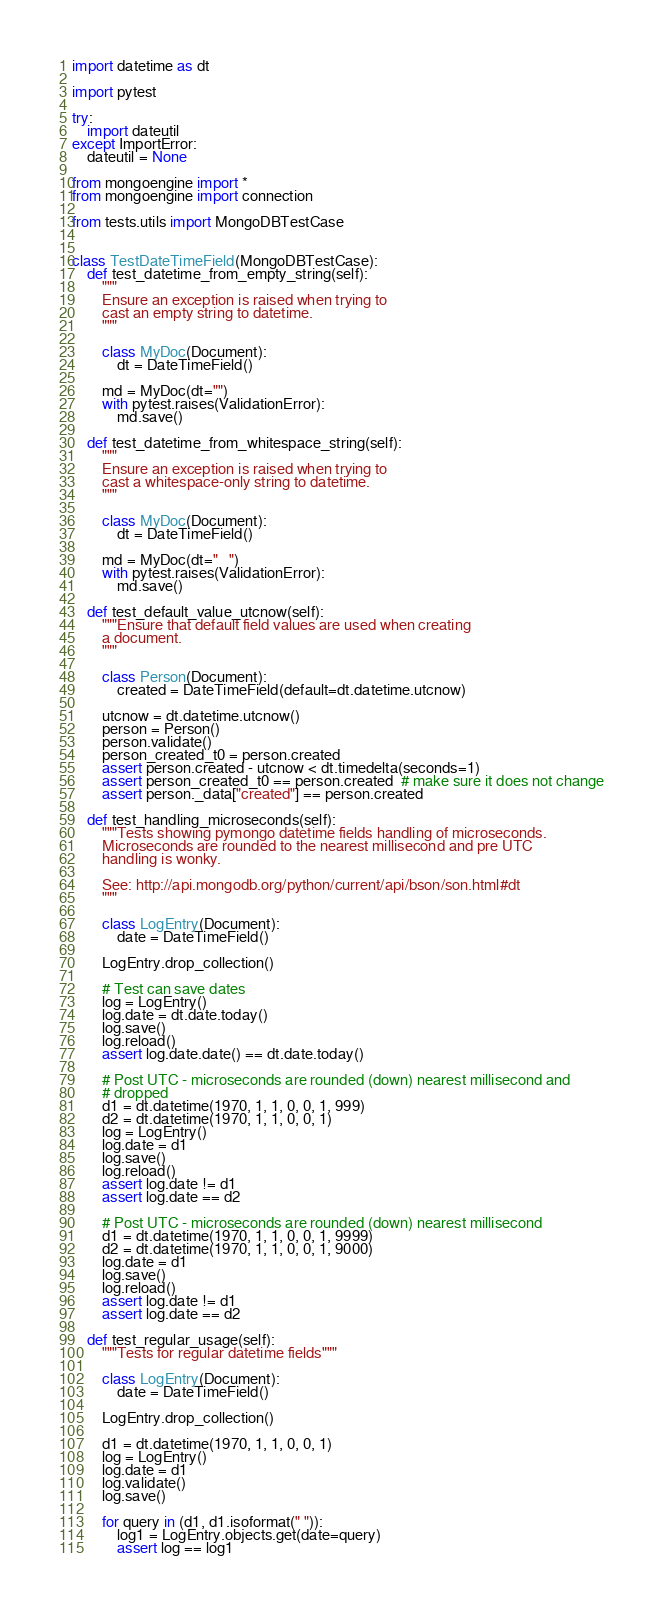Convert code to text. <code><loc_0><loc_0><loc_500><loc_500><_Python_>import datetime as dt

import pytest

try:
    import dateutil
except ImportError:
    dateutil = None

from mongoengine import *
from mongoengine import connection

from tests.utils import MongoDBTestCase


class TestDateTimeField(MongoDBTestCase):
    def test_datetime_from_empty_string(self):
        """
        Ensure an exception is raised when trying to
        cast an empty string to datetime.
        """

        class MyDoc(Document):
            dt = DateTimeField()

        md = MyDoc(dt="")
        with pytest.raises(ValidationError):
            md.save()

    def test_datetime_from_whitespace_string(self):
        """
        Ensure an exception is raised when trying to
        cast a whitespace-only string to datetime.
        """

        class MyDoc(Document):
            dt = DateTimeField()

        md = MyDoc(dt="   ")
        with pytest.raises(ValidationError):
            md.save()

    def test_default_value_utcnow(self):
        """Ensure that default field values are used when creating
        a document.
        """

        class Person(Document):
            created = DateTimeField(default=dt.datetime.utcnow)

        utcnow = dt.datetime.utcnow()
        person = Person()
        person.validate()
        person_created_t0 = person.created
        assert person.created - utcnow < dt.timedelta(seconds=1)
        assert person_created_t0 == person.created  # make sure it does not change
        assert person._data["created"] == person.created

    def test_handling_microseconds(self):
        """Tests showing pymongo datetime fields handling of microseconds.
        Microseconds are rounded to the nearest millisecond and pre UTC
        handling is wonky.

        See: http://api.mongodb.org/python/current/api/bson/son.html#dt
        """

        class LogEntry(Document):
            date = DateTimeField()

        LogEntry.drop_collection()

        # Test can save dates
        log = LogEntry()
        log.date = dt.date.today()
        log.save()
        log.reload()
        assert log.date.date() == dt.date.today()

        # Post UTC - microseconds are rounded (down) nearest millisecond and
        # dropped
        d1 = dt.datetime(1970, 1, 1, 0, 0, 1, 999)
        d2 = dt.datetime(1970, 1, 1, 0, 0, 1)
        log = LogEntry()
        log.date = d1
        log.save()
        log.reload()
        assert log.date != d1
        assert log.date == d2

        # Post UTC - microseconds are rounded (down) nearest millisecond
        d1 = dt.datetime(1970, 1, 1, 0, 0, 1, 9999)
        d2 = dt.datetime(1970, 1, 1, 0, 0, 1, 9000)
        log.date = d1
        log.save()
        log.reload()
        assert log.date != d1
        assert log.date == d2

    def test_regular_usage(self):
        """Tests for regular datetime fields"""

        class LogEntry(Document):
            date = DateTimeField()

        LogEntry.drop_collection()

        d1 = dt.datetime(1970, 1, 1, 0, 0, 1)
        log = LogEntry()
        log.date = d1
        log.validate()
        log.save()

        for query in (d1, d1.isoformat(" ")):
            log1 = LogEntry.objects.get(date=query)
            assert log == log1
</code> 